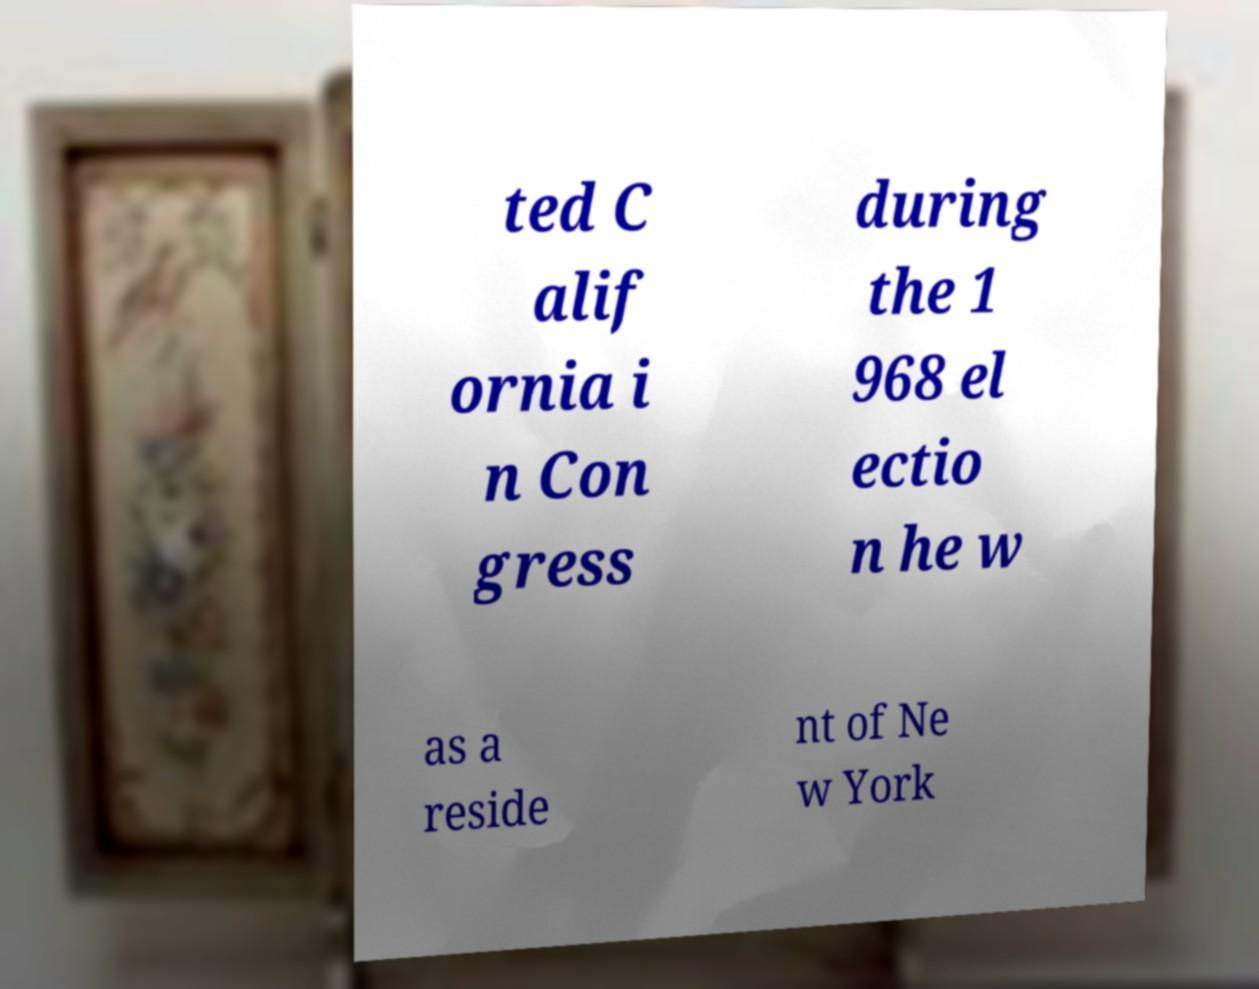I need the written content from this picture converted into text. Can you do that? ted C alif ornia i n Con gress during the 1 968 el ectio n he w as a reside nt of Ne w York 